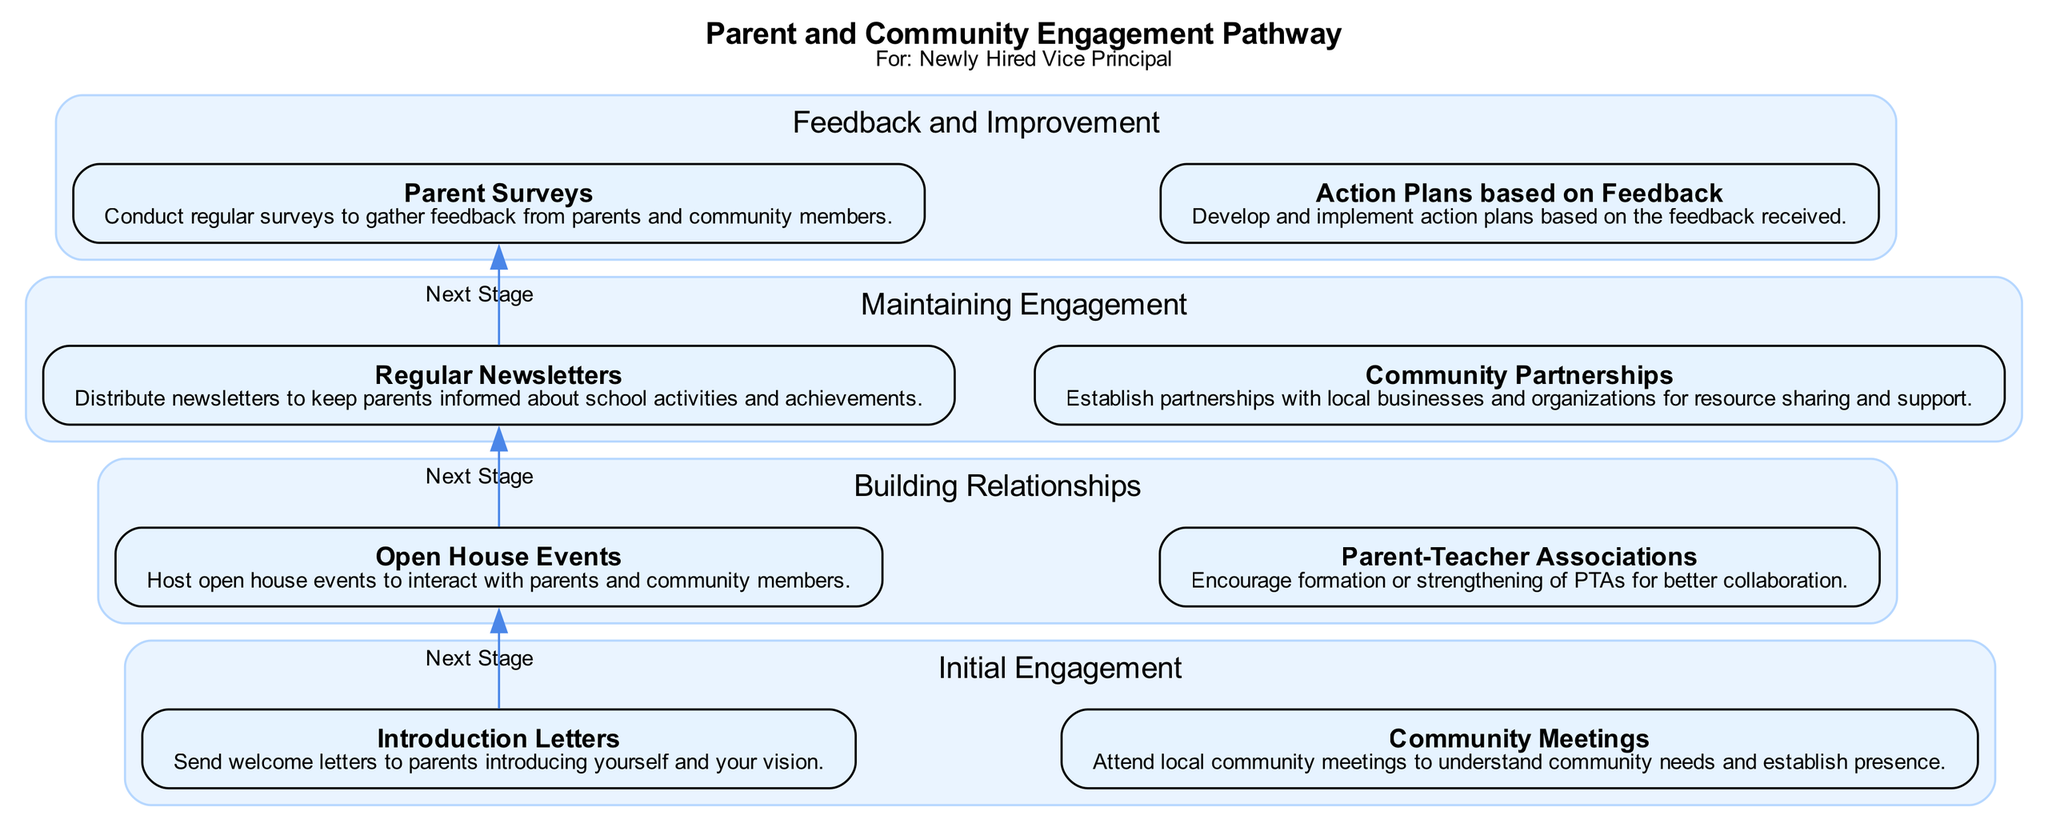What is the first stage in the pathway? The diagram presents four stages, with the first one clearly labeled as "Initial Engagement".
Answer: Initial Engagement How many elements are there in the "Building Relationships" stage? In the "Building Relationships" stage, there are two elements listed: "Open House Events" and "Parent-Teacher Associations".
Answer: 2 What type of events are hosted in the "Building Relationships" stage? Under this stage, the diagram specifies "Open House Events" as a key activity for interaction with parents and the community.
Answer: Open House Events What action is taken in the "Feedback and Improvement" stage? This stage outlines two critical actions: conducting "Parent Surveys" to gather feedback and developing "Action Plans based on Feedback" to implement necessary changes.
Answer: Parent Surveys Which stage comes after "Maintaining Engagement"? The diagram shows that "Feedback and Improvement" follows "Maintaining Engagement" as the next stage in the sequence.
Answer: Feedback and Improvement What is a key strategy to maintain engagement with parents? The "Regular Newsletters" element is identified in the "Maintaining Engagement" stage as a strategy to keep parents informed about school activities.
Answer: Regular Newsletters How many total stages are shown in the diagram? The diagram includes four distinct stages in the Parent and Community Engagement Pathway.
Answer: 4 What signifies the transition between stages in the diagram? The connections labeled "Next Stage" between the first element in each stage demonstrate the transitions between stages in the pathway.
Answer: Next Stage How are community needs understood in the initial engagement? The diagram mentions "Community Meetings" as a method for attending local gatherings and understanding community needs.
Answer: Community Meetings 